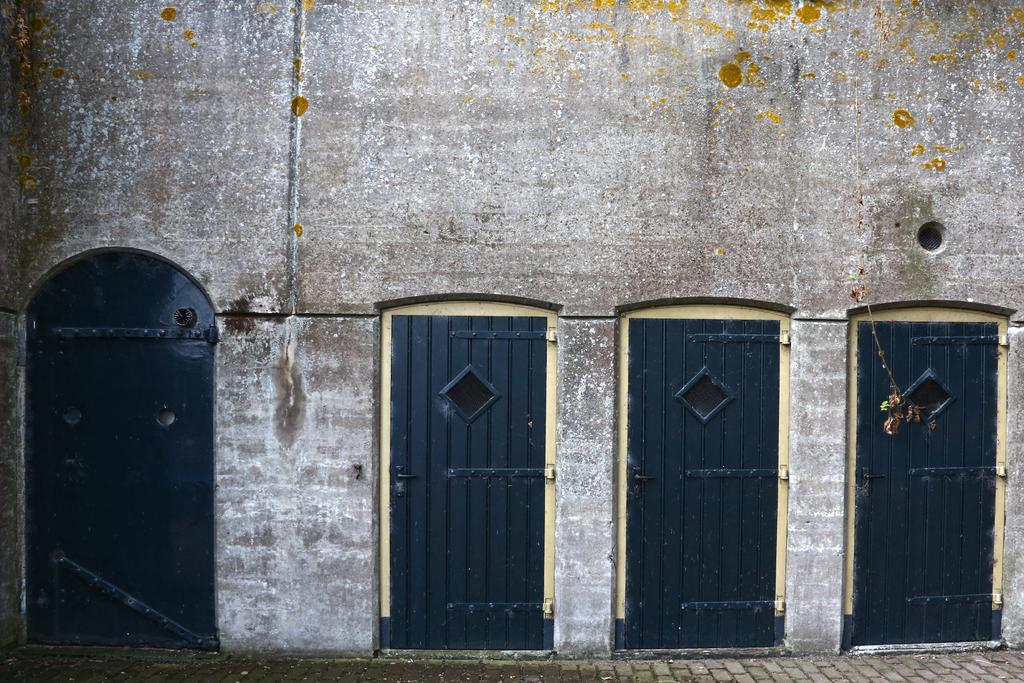What type of architectural feature can be seen in the image? There are doors and a wall visible in the image. Can you describe the doors in the image? The provided facts do not give specific details about the doors, but they are present in the image. What is the primary purpose of the wall in the image? The wall serves as a structural element and may also provide privacy or separation between spaces. How many balloons are floating above the doors in the image? There are no balloons present in the image. What type of experience can be gained by interacting with the wall in the image? The provided facts do not give any information about an experience that can be gained by interacting with the wall. 